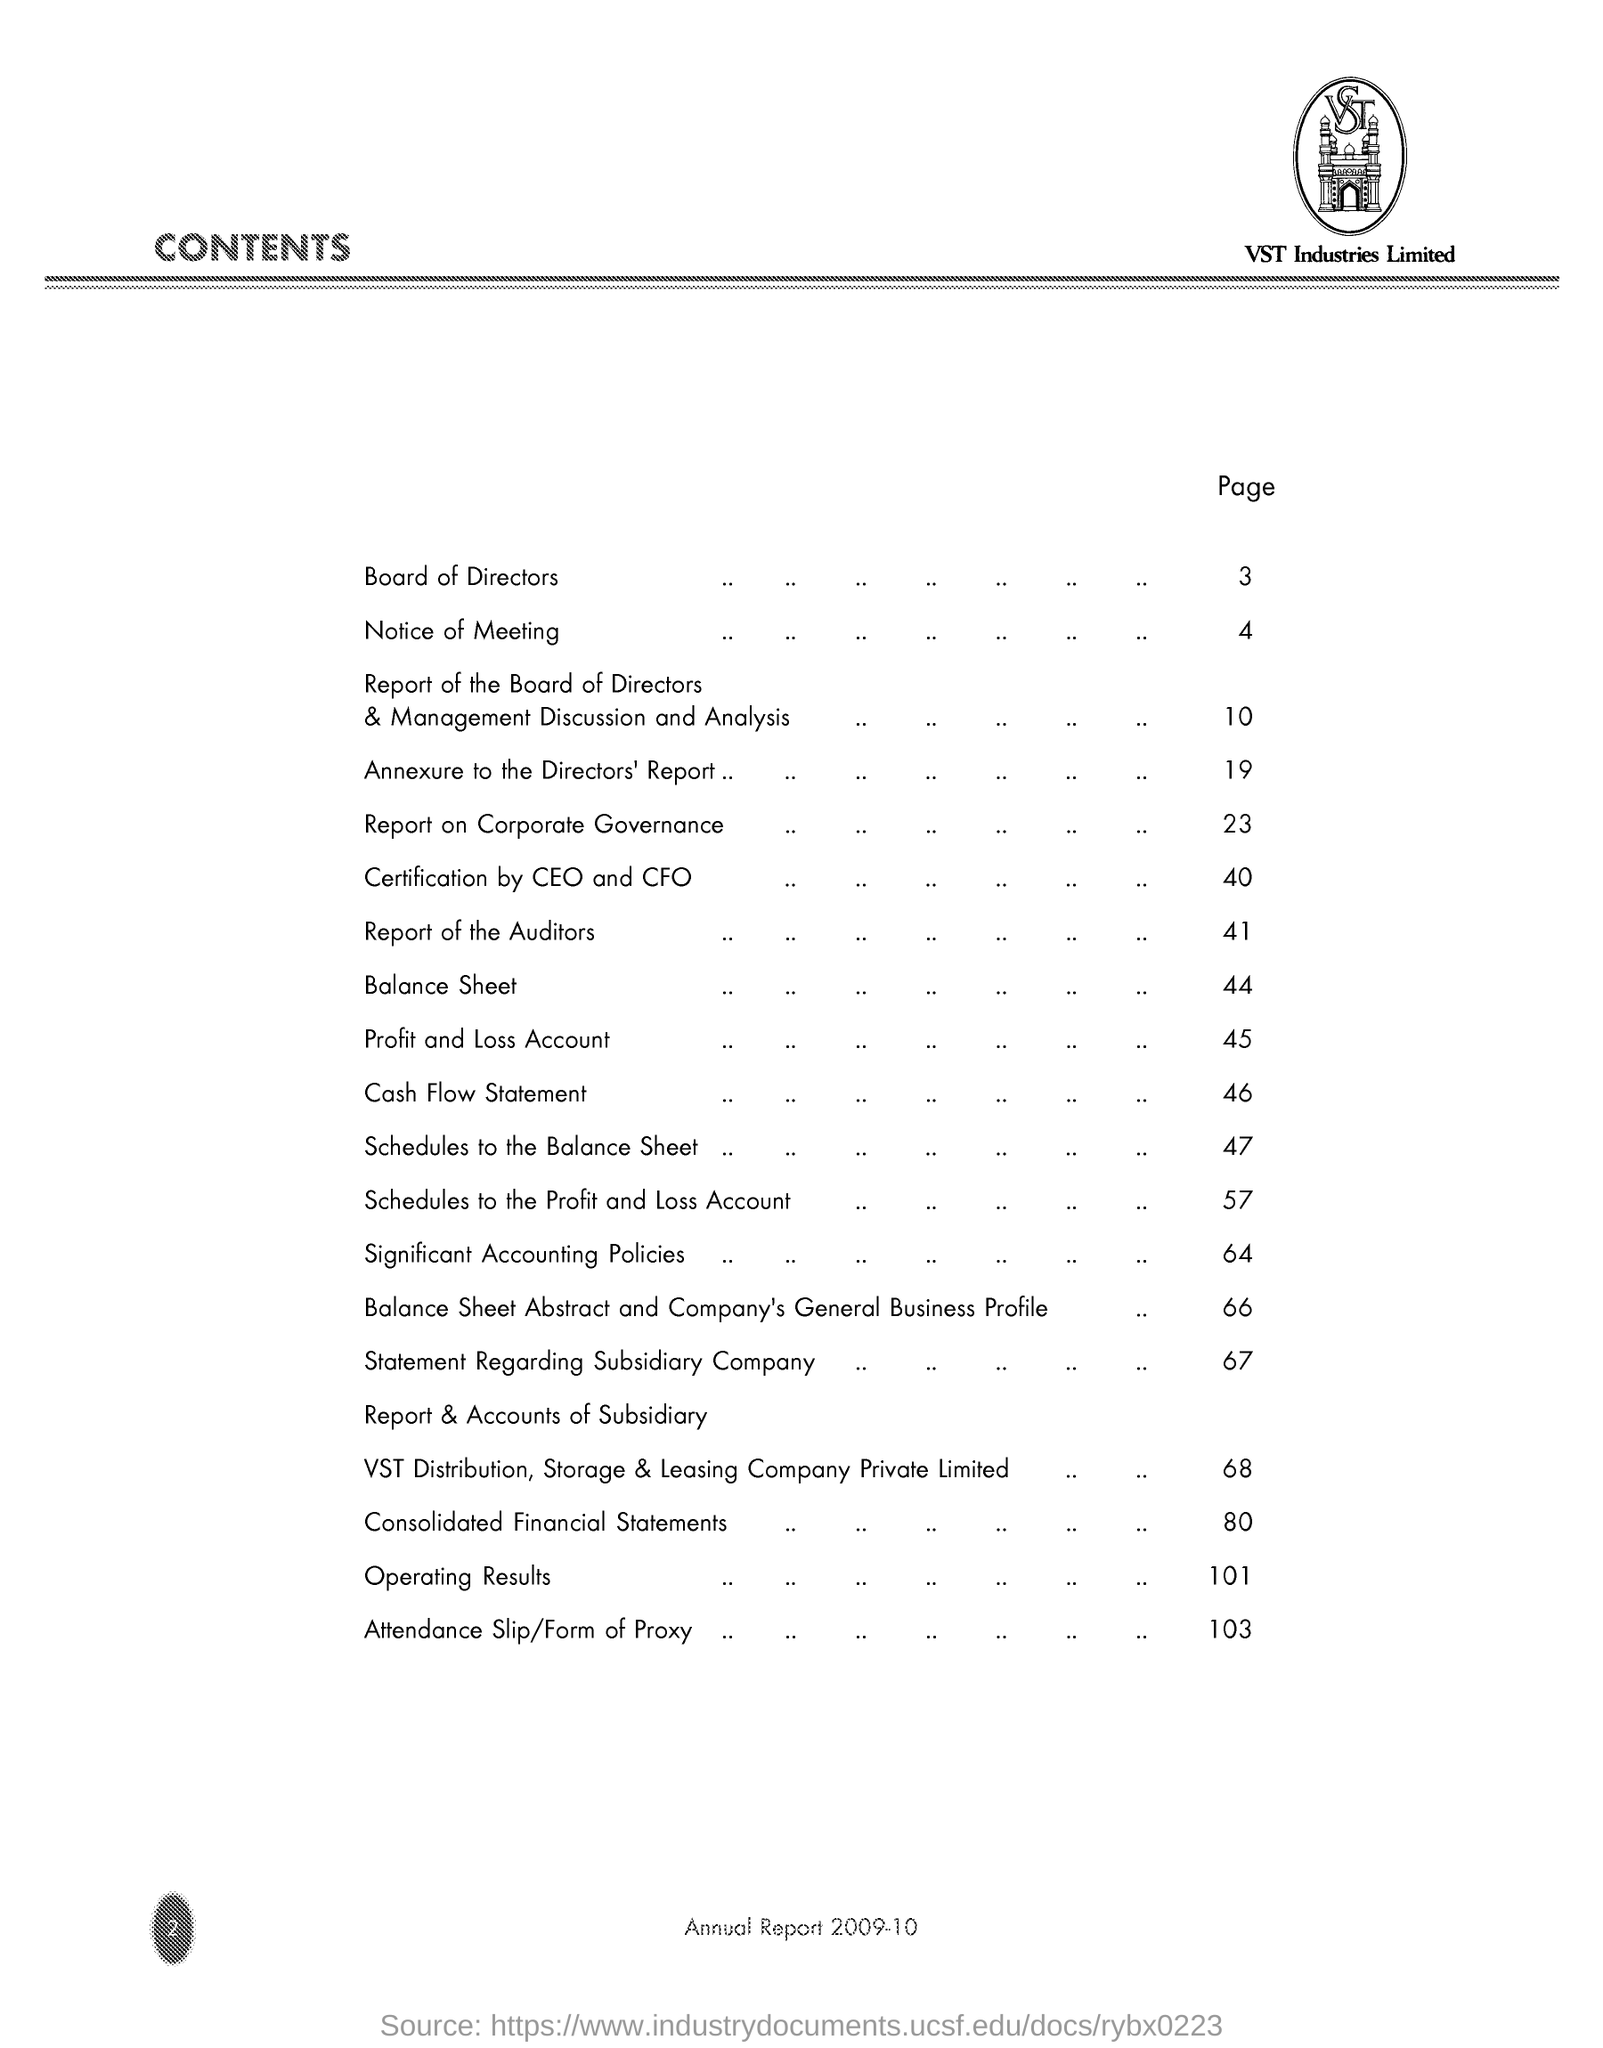Specify some key components in this picture. The page number for the Board of Directors is 3. The title of the document is [insert title here]. The contents of the document are [insert details here]. VST Industries Limited is a company. 